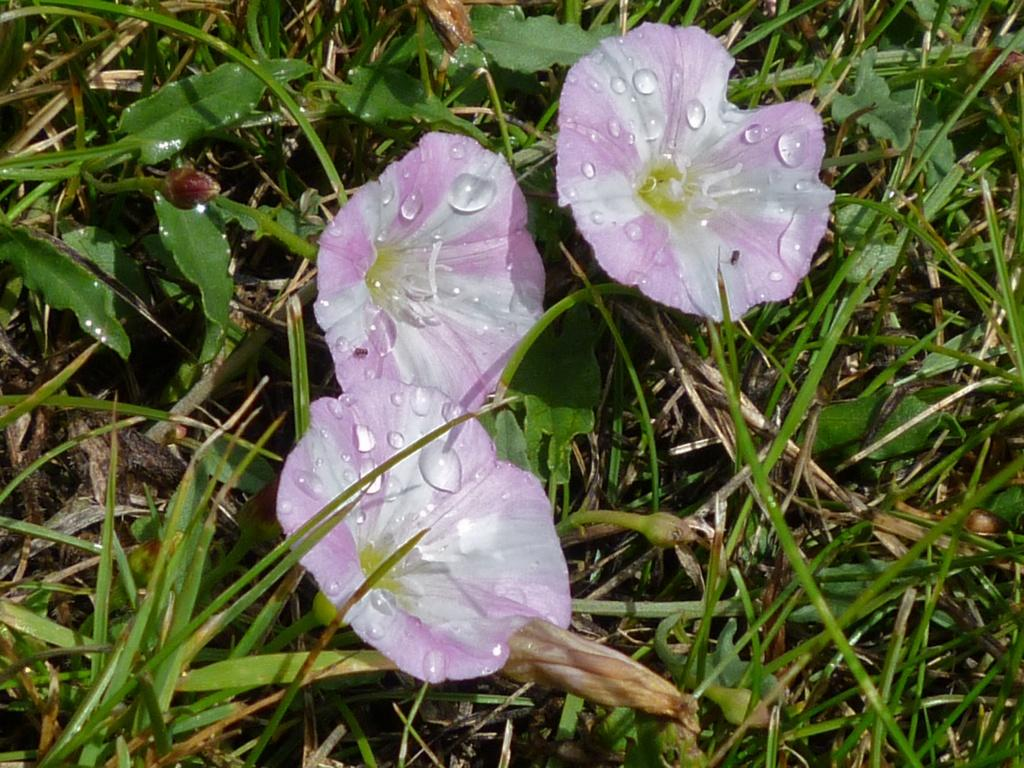What type of vegetation can be seen in the image? There are flowers, buds, leaves, and grass in the image. What is the condition of the flowers in the image? Water bubbles are present on the flowers in the image. What other elements can be seen in the image besides the vegetation? There are no other elements mentioned in the provided facts. What type of stocking is being sold at the price mentioned in the image? There is no mention of stocking or price in the provided facts, so it is not possible to answer that question. 